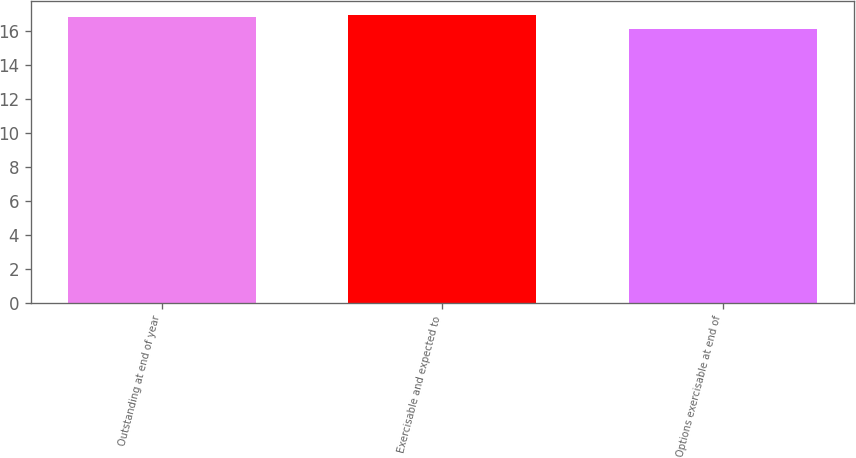<chart> <loc_0><loc_0><loc_500><loc_500><bar_chart><fcel>Outstanding at end of year<fcel>Exercisable and expected to<fcel>Options exercisable at end of<nl><fcel>16.81<fcel>16.92<fcel>16.09<nl></chart> 